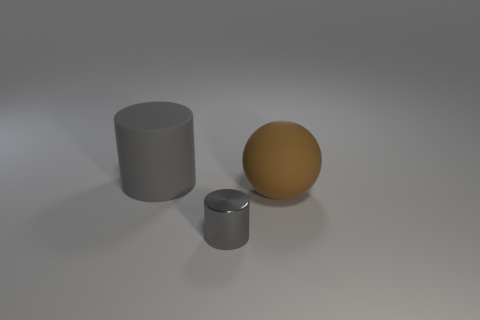Add 3 big purple shiny balls. How many objects exist? 6 Subtract all cylinders. How many objects are left? 1 Add 1 big brown spheres. How many big brown spheres exist? 2 Subtract 0 purple cylinders. How many objects are left? 3 Subtract all green shiny cubes. Subtract all large brown matte balls. How many objects are left? 2 Add 1 tiny objects. How many tiny objects are left? 2 